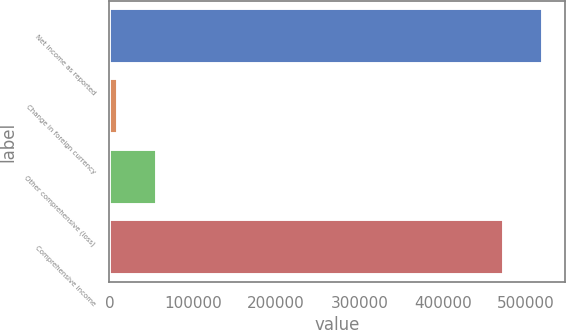Convert chart to OTSL. <chart><loc_0><loc_0><loc_500><loc_500><bar_chart><fcel>Net income as reported<fcel>Change in foreign currency<fcel>Other comprehensive (loss)<fcel>Comprehensive income<nl><fcel>520262<fcel>10220<fcel>57516.5<fcel>472965<nl></chart> 